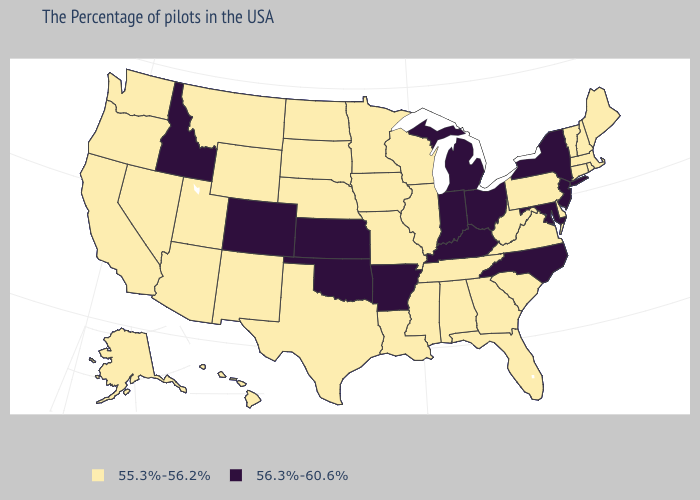What is the highest value in the USA?
Answer briefly. 56.3%-60.6%. Which states hav the highest value in the Northeast?
Answer briefly. New York, New Jersey. What is the highest value in the Northeast ?
Short answer required. 56.3%-60.6%. Among the states that border Vermont , does New Hampshire have the lowest value?
Answer briefly. Yes. What is the value of Michigan?
Short answer required. 56.3%-60.6%. Which states hav the highest value in the South?
Write a very short answer. Maryland, North Carolina, Kentucky, Arkansas, Oklahoma. Does Massachusetts have a higher value than Arizona?
Quick response, please. No. What is the lowest value in the USA?
Write a very short answer. 55.3%-56.2%. Does the map have missing data?
Give a very brief answer. No. Does New Hampshire have the lowest value in the Northeast?
Keep it brief. Yes. Name the states that have a value in the range 55.3%-56.2%?
Give a very brief answer. Maine, Massachusetts, Rhode Island, New Hampshire, Vermont, Connecticut, Delaware, Pennsylvania, Virginia, South Carolina, West Virginia, Florida, Georgia, Alabama, Tennessee, Wisconsin, Illinois, Mississippi, Louisiana, Missouri, Minnesota, Iowa, Nebraska, Texas, South Dakota, North Dakota, Wyoming, New Mexico, Utah, Montana, Arizona, Nevada, California, Washington, Oregon, Alaska, Hawaii. Is the legend a continuous bar?
Quick response, please. No. What is the lowest value in the USA?
Concise answer only. 55.3%-56.2%. Name the states that have a value in the range 56.3%-60.6%?
Keep it brief. New York, New Jersey, Maryland, North Carolina, Ohio, Michigan, Kentucky, Indiana, Arkansas, Kansas, Oklahoma, Colorado, Idaho. What is the value of Iowa?
Short answer required. 55.3%-56.2%. 